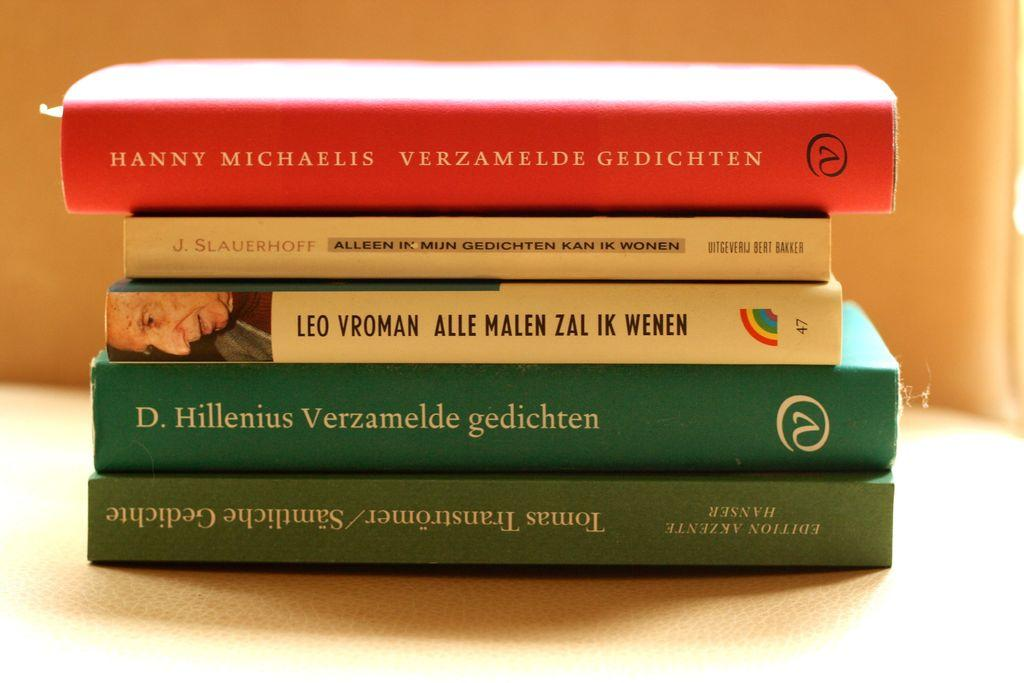<image>
Offer a succinct explanation of the picture presented. A Book titled "Verzamelde Gedichten" in red by Hanny Micaelis. 